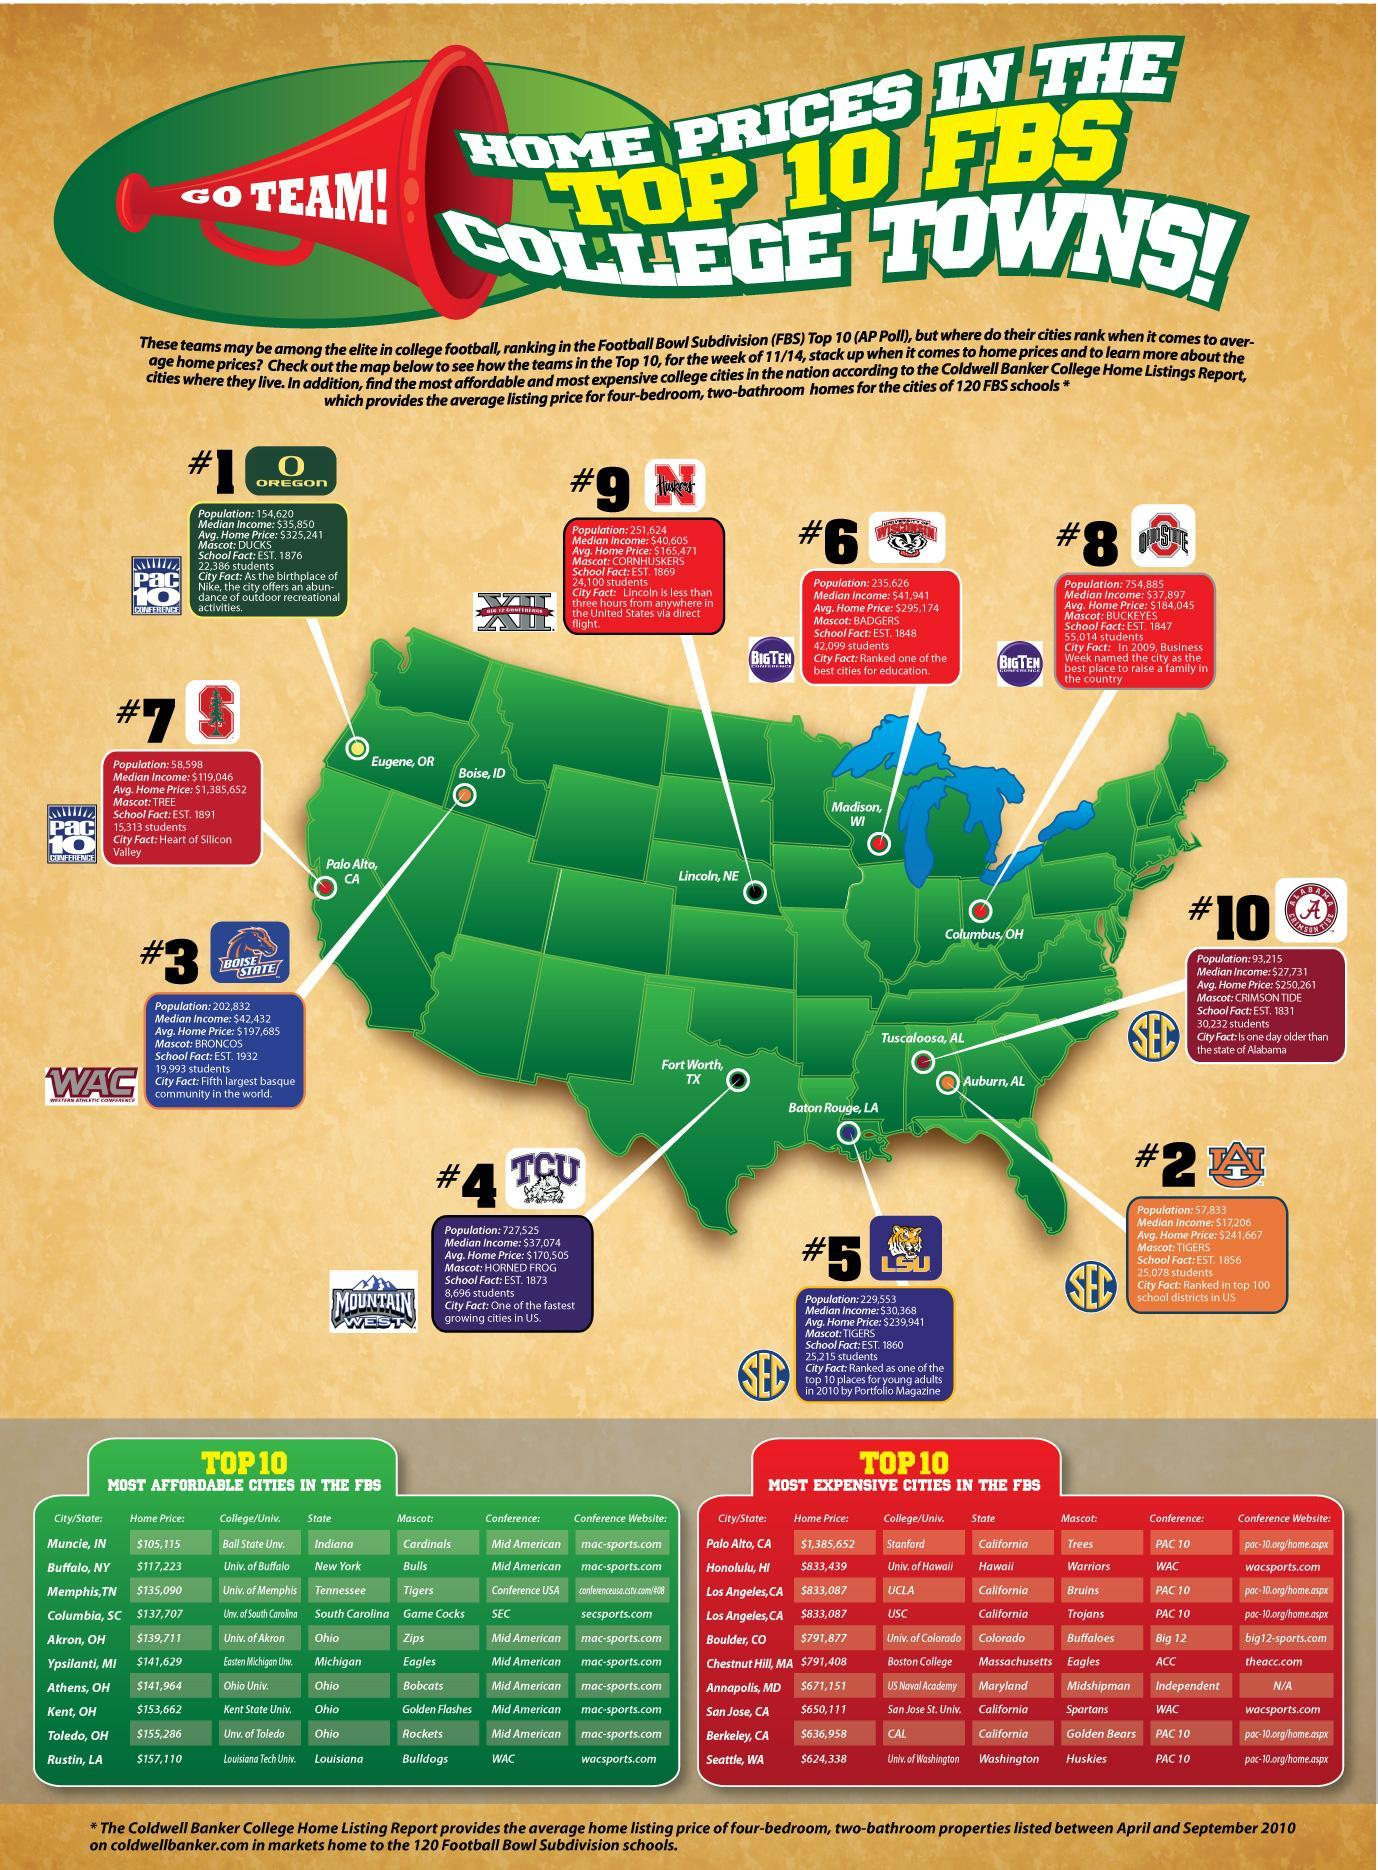Which location is listed in the eighth position as the most affordable cities in FBS?
Answer the question with a short phrase. Kent, OH How many college football teams are based out of Alabama? 2 What is the mascot of university listed in the third row and third column? Bruins What is the average home price in Madison, Wisconsin, $251,624, $295,174, or $27,731? $295,174 What is the average price difference of houses between the college cities ranked 1 and 10 ? $74,980 Which city ranks seventh in football bowl sub division ? Palo Alto, CA How many cities from California are listed as the most expensive cities in the FBS? 4 Which university ranks fifth in the most affordable cities in FBS? Univ. of Akron Which football team's mascot as buckeyes, N Huskers, University of Wisconsin, or Ohio State? Ohio State Which football team is based from Texas, TCU, LSU, or Boise state? TCU 